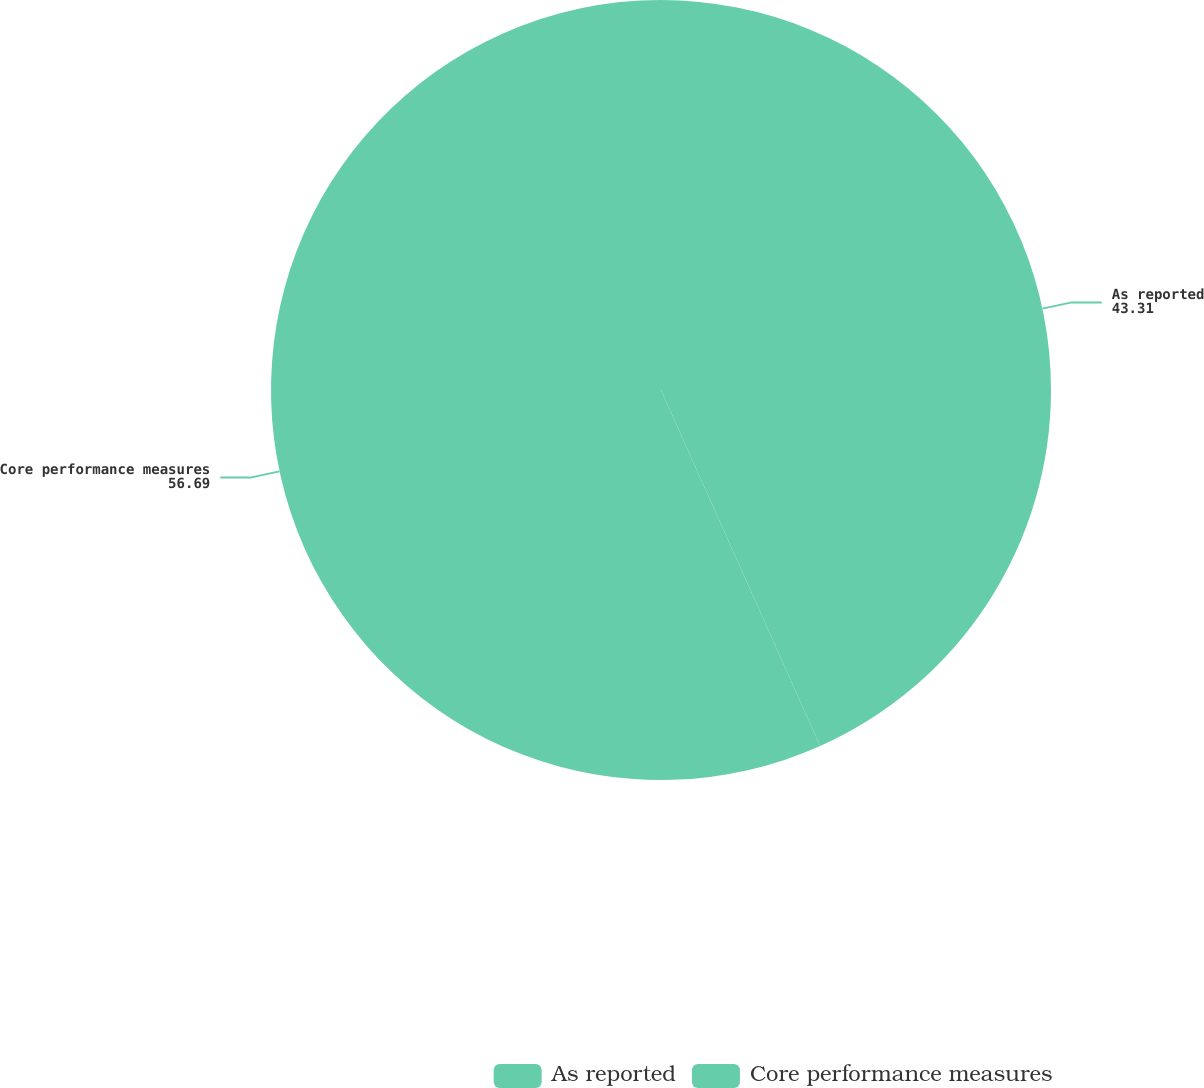Convert chart to OTSL. <chart><loc_0><loc_0><loc_500><loc_500><pie_chart><fcel>As reported<fcel>Core performance measures<nl><fcel>43.31%<fcel>56.69%<nl></chart> 